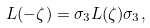Convert formula to latex. <formula><loc_0><loc_0><loc_500><loc_500>L ( - \zeta ) = \sigma _ { 3 } L ( \zeta ) \sigma _ { 3 } ,</formula> 